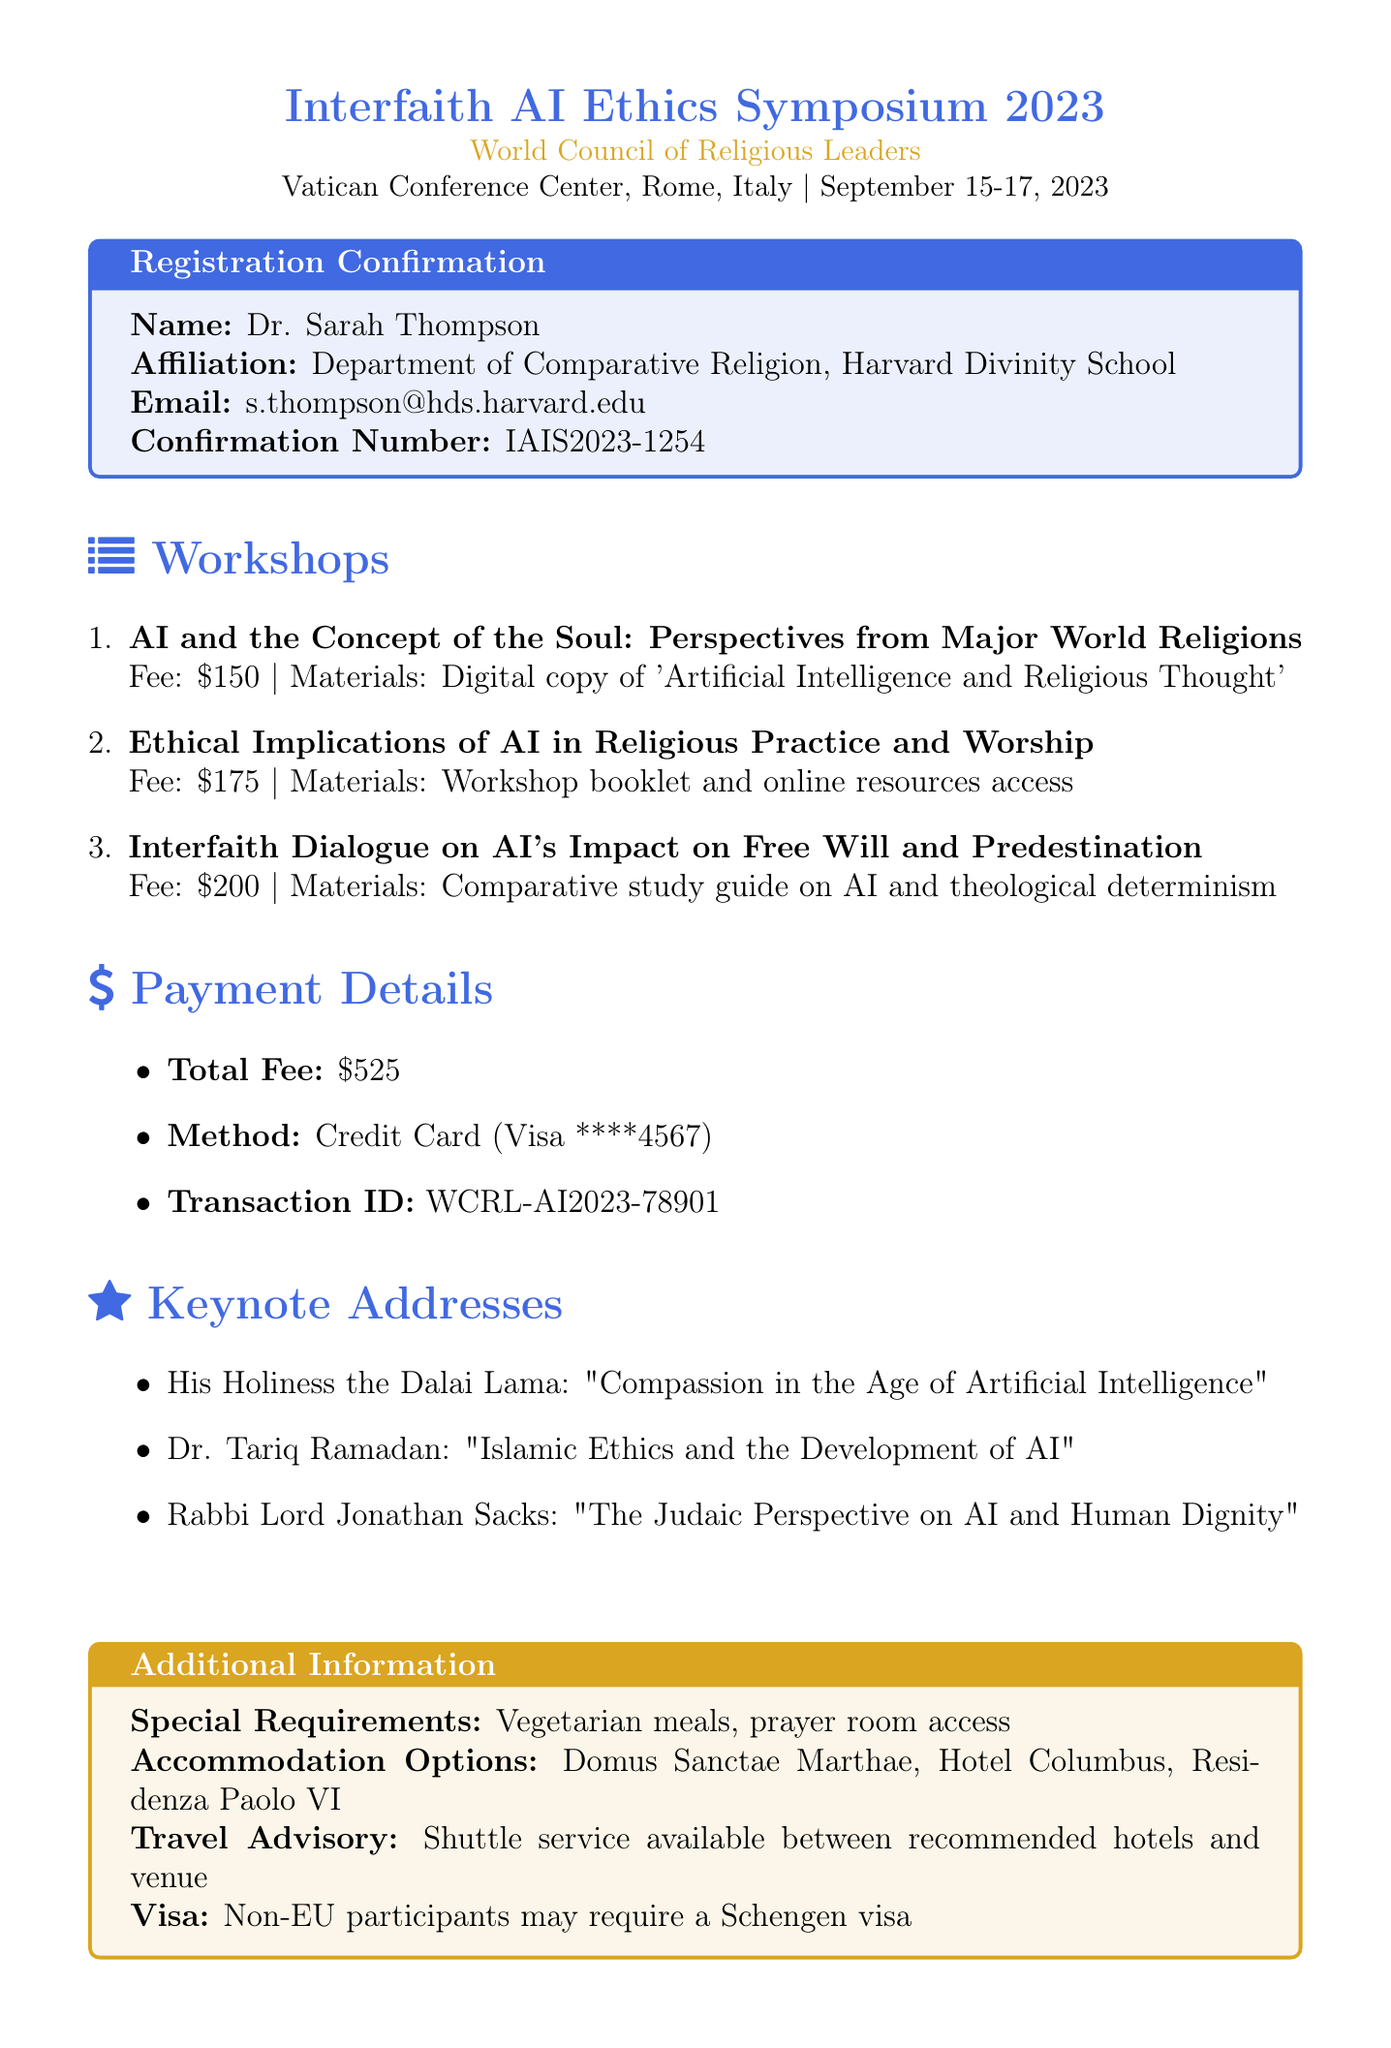What is the title of the conference? The title of the conference is provided in the document's header.
Answer: Interfaith AI Ethics Symposium 2023 Who is the organizer of the event? The organizer's name is specified right below the conference title.
Answer: World Council of Religious Leaders What are the dates of the conference? The document states the dates of the event clearly in the introductory section.
Answer: September 15-17, 2023 How much is the fee for the workshop on ethical implications? The fee for this specific workshop is explicitly mentioned in the workshop list.
Answer: $175 What special requirements has the registrant requested? The document lists specific needs under additional information.
Answer: Vegetarian meals, prayer room access Who is the speaker for the keynote address on Islamic ethics? This information is found in the keynote addresses section of the document.
Answer: Dr. Tariq Ramadan What method of payment was used for registration? The payment details section includes the method used for the transaction.
Answer: Credit Card How many workshops are listed in the document? The workshops section outlines the total number of workshops available.
Answer: Three What is the confirmation number for the registration? The confirmation number is provided in the registration confirmation box.
Answer: IAIS2023-1254 